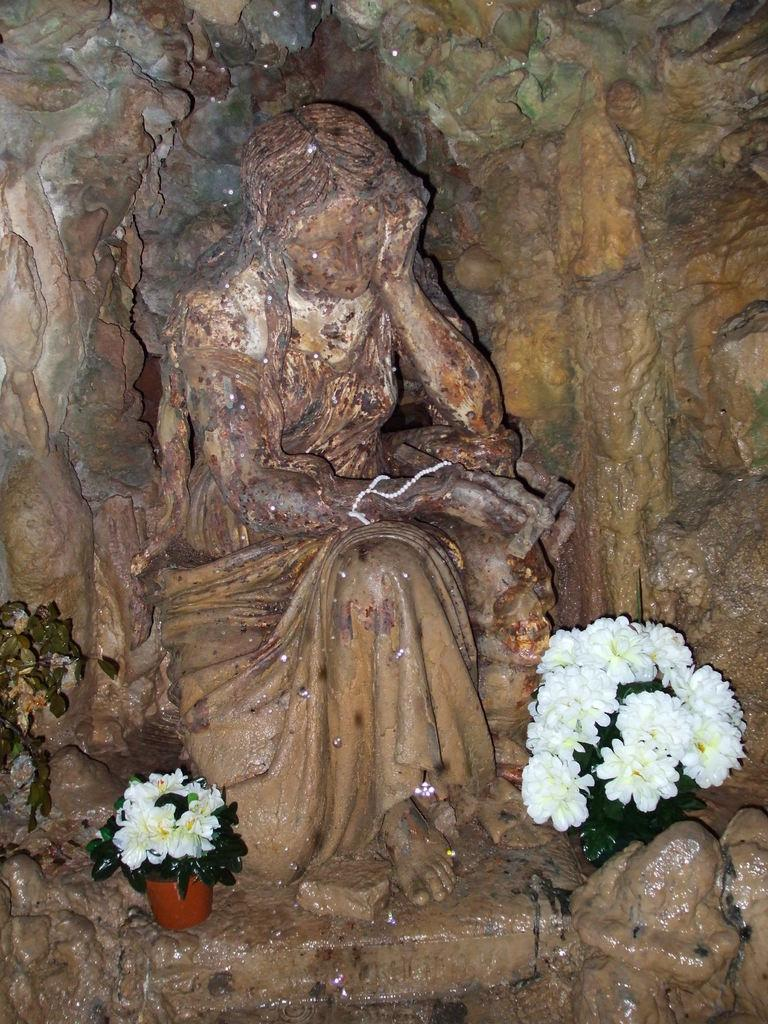How many flower pots are in the image? There are two flower pots in the image. What color are the flowers in the pots? The flowers are white. What color are the flower pots? The pots are brown. What can be seen in the background of the image? There is a statue in the background of the image. What color is the statue? The statue is brown. Who won the competition between the porter and the bear in the image? There is no competition between a porter and a bear present in the image. 